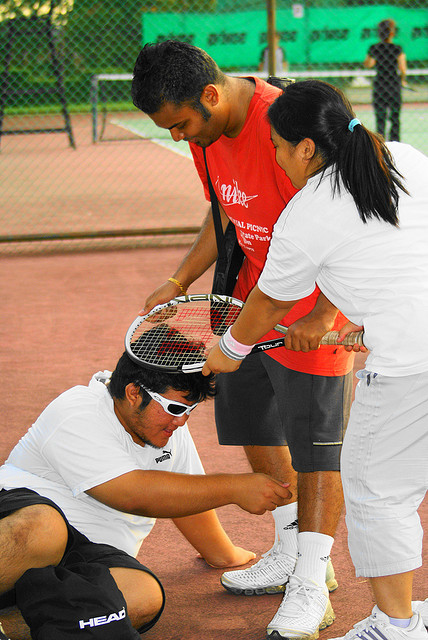How many people are wearing sunglasses? 1 